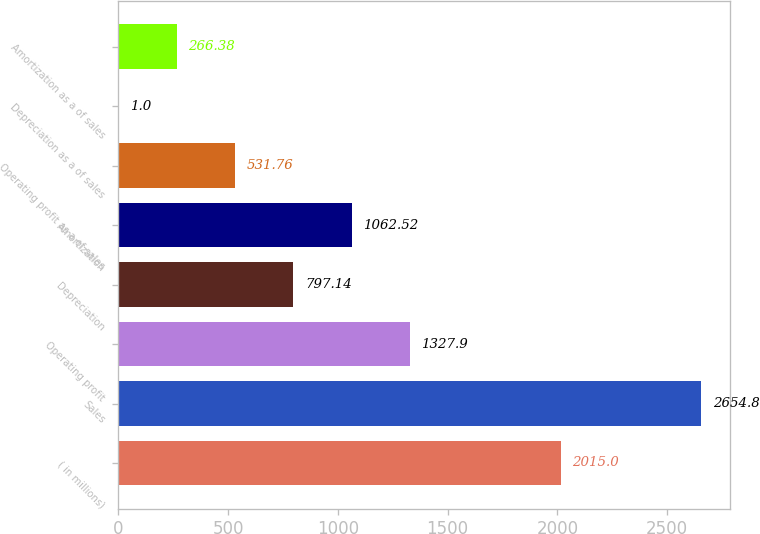Convert chart to OTSL. <chart><loc_0><loc_0><loc_500><loc_500><bar_chart><fcel>( in millions)<fcel>Sales<fcel>Operating profit<fcel>Depreciation<fcel>Amortization<fcel>Operating profit as a of sales<fcel>Depreciation as a of sales<fcel>Amortization as a of sales<nl><fcel>2015<fcel>2654.8<fcel>1327.9<fcel>797.14<fcel>1062.52<fcel>531.76<fcel>1<fcel>266.38<nl></chart> 